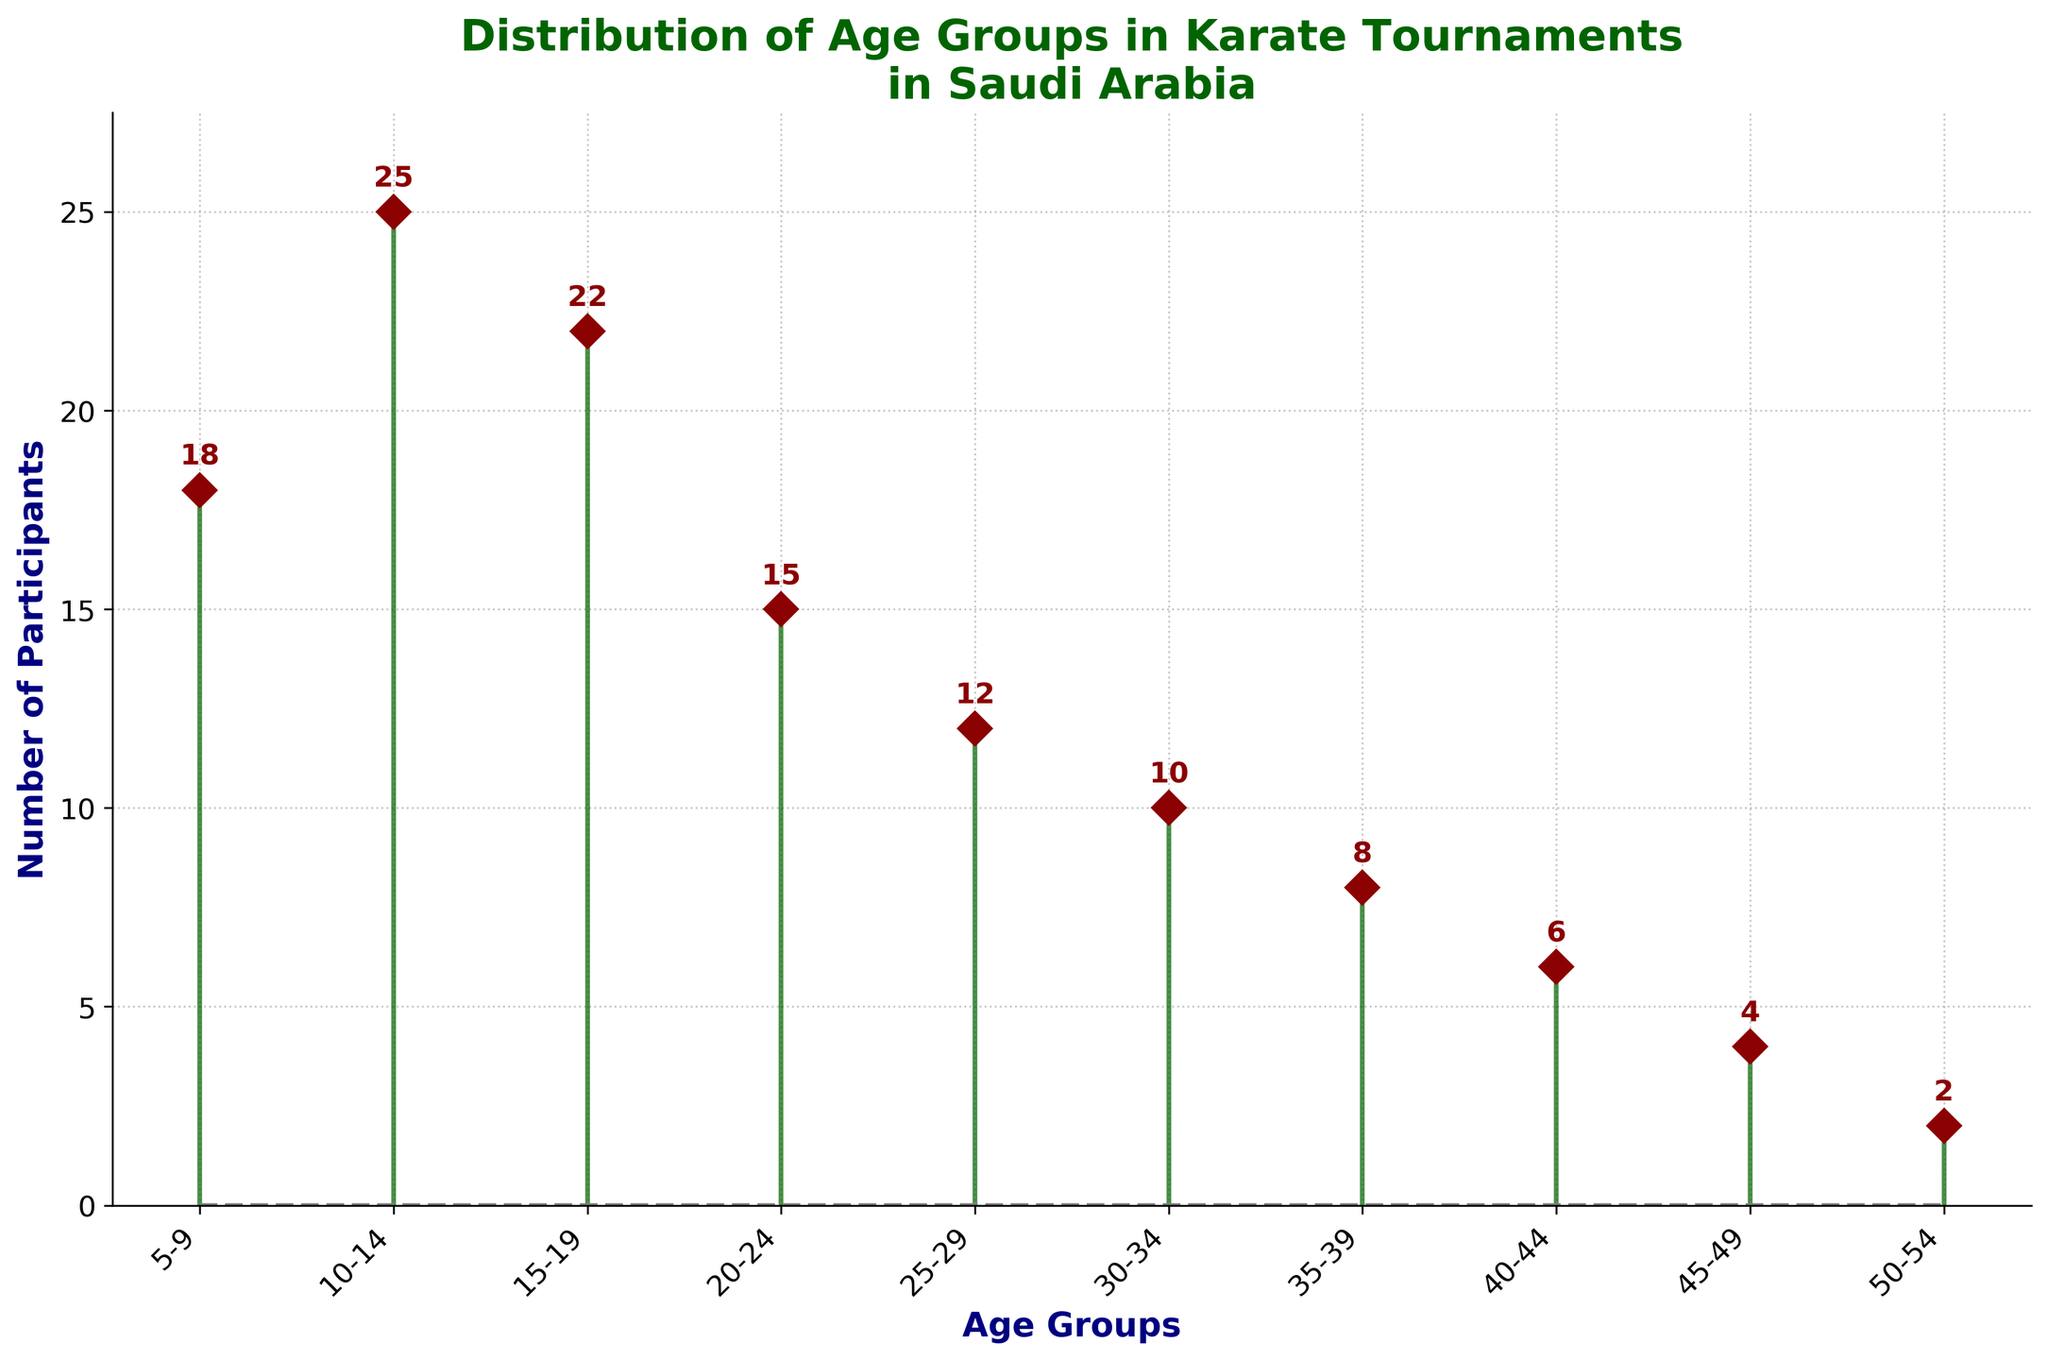What's the title of the figure? The title is displayed at the top of the figure and reads "Distribution of Age Groups in Karate Tournaments in Saudi Arabia".
Answer: Distribution of Age Groups in Karate Tournaments in Saudi Arabia Which age group has the highest number of participants? By looking at the figure, the age group with the longest stem is 10-14, and the number at the top of this stem is 25.
Answer: 10-14 What is the number of participants in the 45-49 age group? The stem corresponding to the 45-49 age group in the figure has the marker labeled with the number 4 at its top.
Answer: 4 How many age groups have more than 20 participants? By observing each stem, the groups 10-14 and 15-19 have more than 20 participants; hence, there are 2 such age groups.
Answer: 2 Which age group has fewer participants: 35-39 or 40-44? By comparing the stems corresponding to the age groups, 40-44 has a stem with 6 participants while 35-39 has a stem with 8 participants. Hence, 40-44 has fewer participants.
Answer: 40-44 What is the total number of participants across all age groups? By adding the number of participants from each age group: 18 + 25 + 22 + 15 + 12 + 10 + 8 + 6 + 4 + 2 = 122.
Answer: 122 What is the average number of participants per age group? The total number of participants is 122, and there are 10 age groups. The average is calculated as 122 / 10 = 12.2.
Answer: 12.2 Which age group has the smallest number of participants? The stem with the smallest number is for the 50-54 age group, where the marker at the top is labeled with 2 participants.
Answer: 50-54 Is the number of participants in the 20-24 age group greater or lesser than in the 25-29 age group? The 20-24 age group has 15 participants, while the 25-29 age group has 12 participants. Hence, the 20-24 group has more participants.
Answer: Greater By how much do the participants in the 5-9 age group exceed those in the 35-39 age group? The 5-9 age group has 18 participants and the 35-39 age group has 8 participants. The difference is 18 - 8 = 10.
Answer: 10 